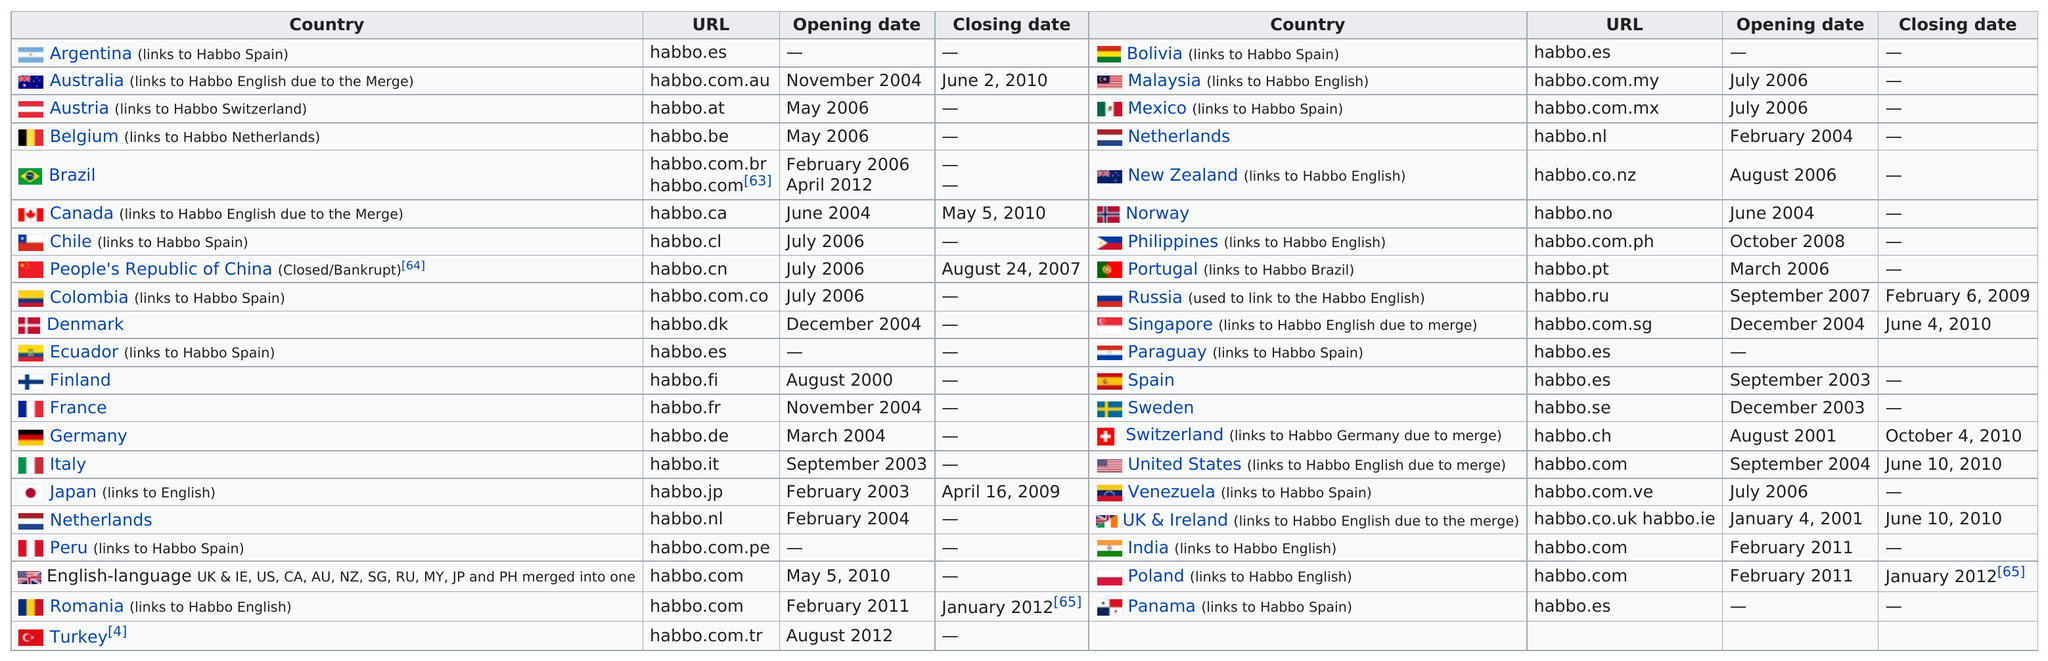Highlight a few significant elements in this photo. Russia used the Habbo service for a period of one year and five months. In 2006, it is reported that approximately 5 websites were opened. The operation of Habbo in the People's Republic of China lasted for a total of 1 year and 1 month. Russia was the first country to open its borders to Western cultural influences, which occurred before Australia established a closing date for its immigration policies. The Australian URL was open for approximately 6 years. 